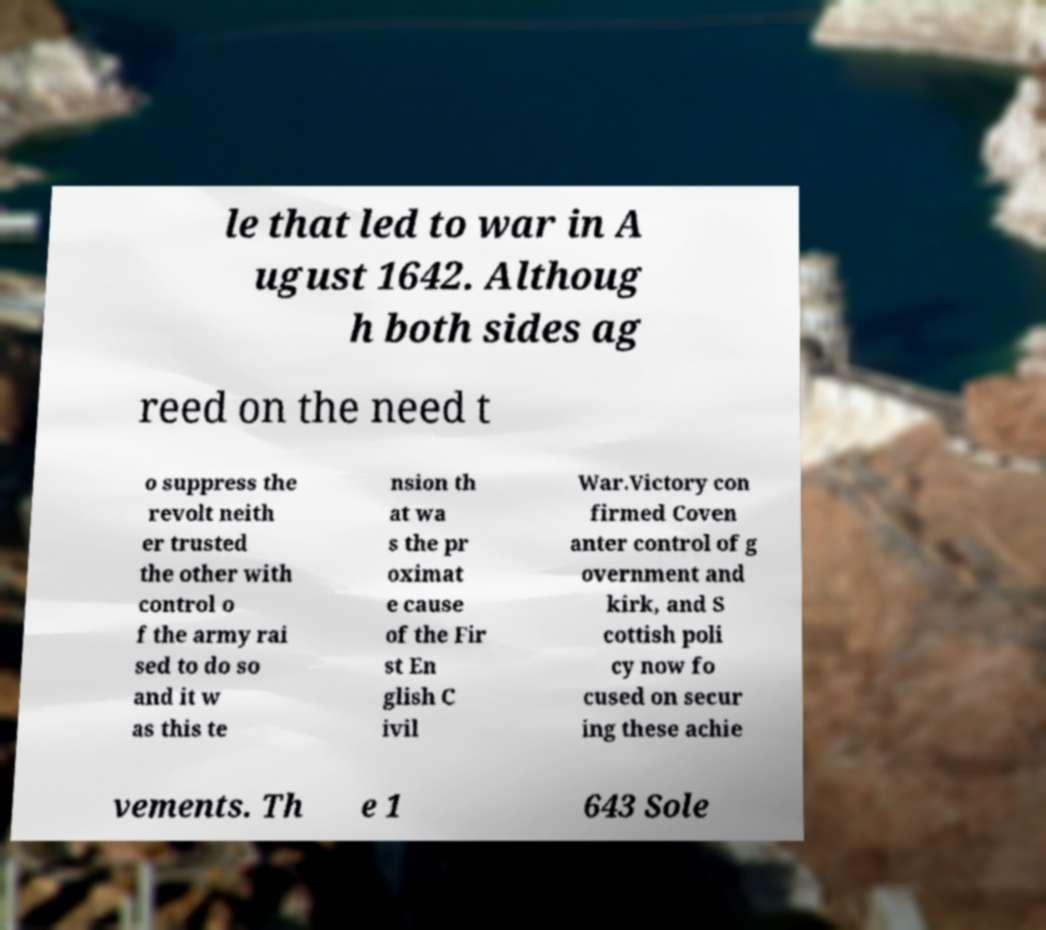Please identify and transcribe the text found in this image. le that led to war in A ugust 1642. Althoug h both sides ag reed on the need t o suppress the revolt neith er trusted the other with control o f the army rai sed to do so and it w as this te nsion th at wa s the pr oximat e cause of the Fir st En glish C ivil War.Victory con firmed Coven anter control of g overnment and kirk, and S cottish poli cy now fo cused on secur ing these achie vements. Th e 1 643 Sole 